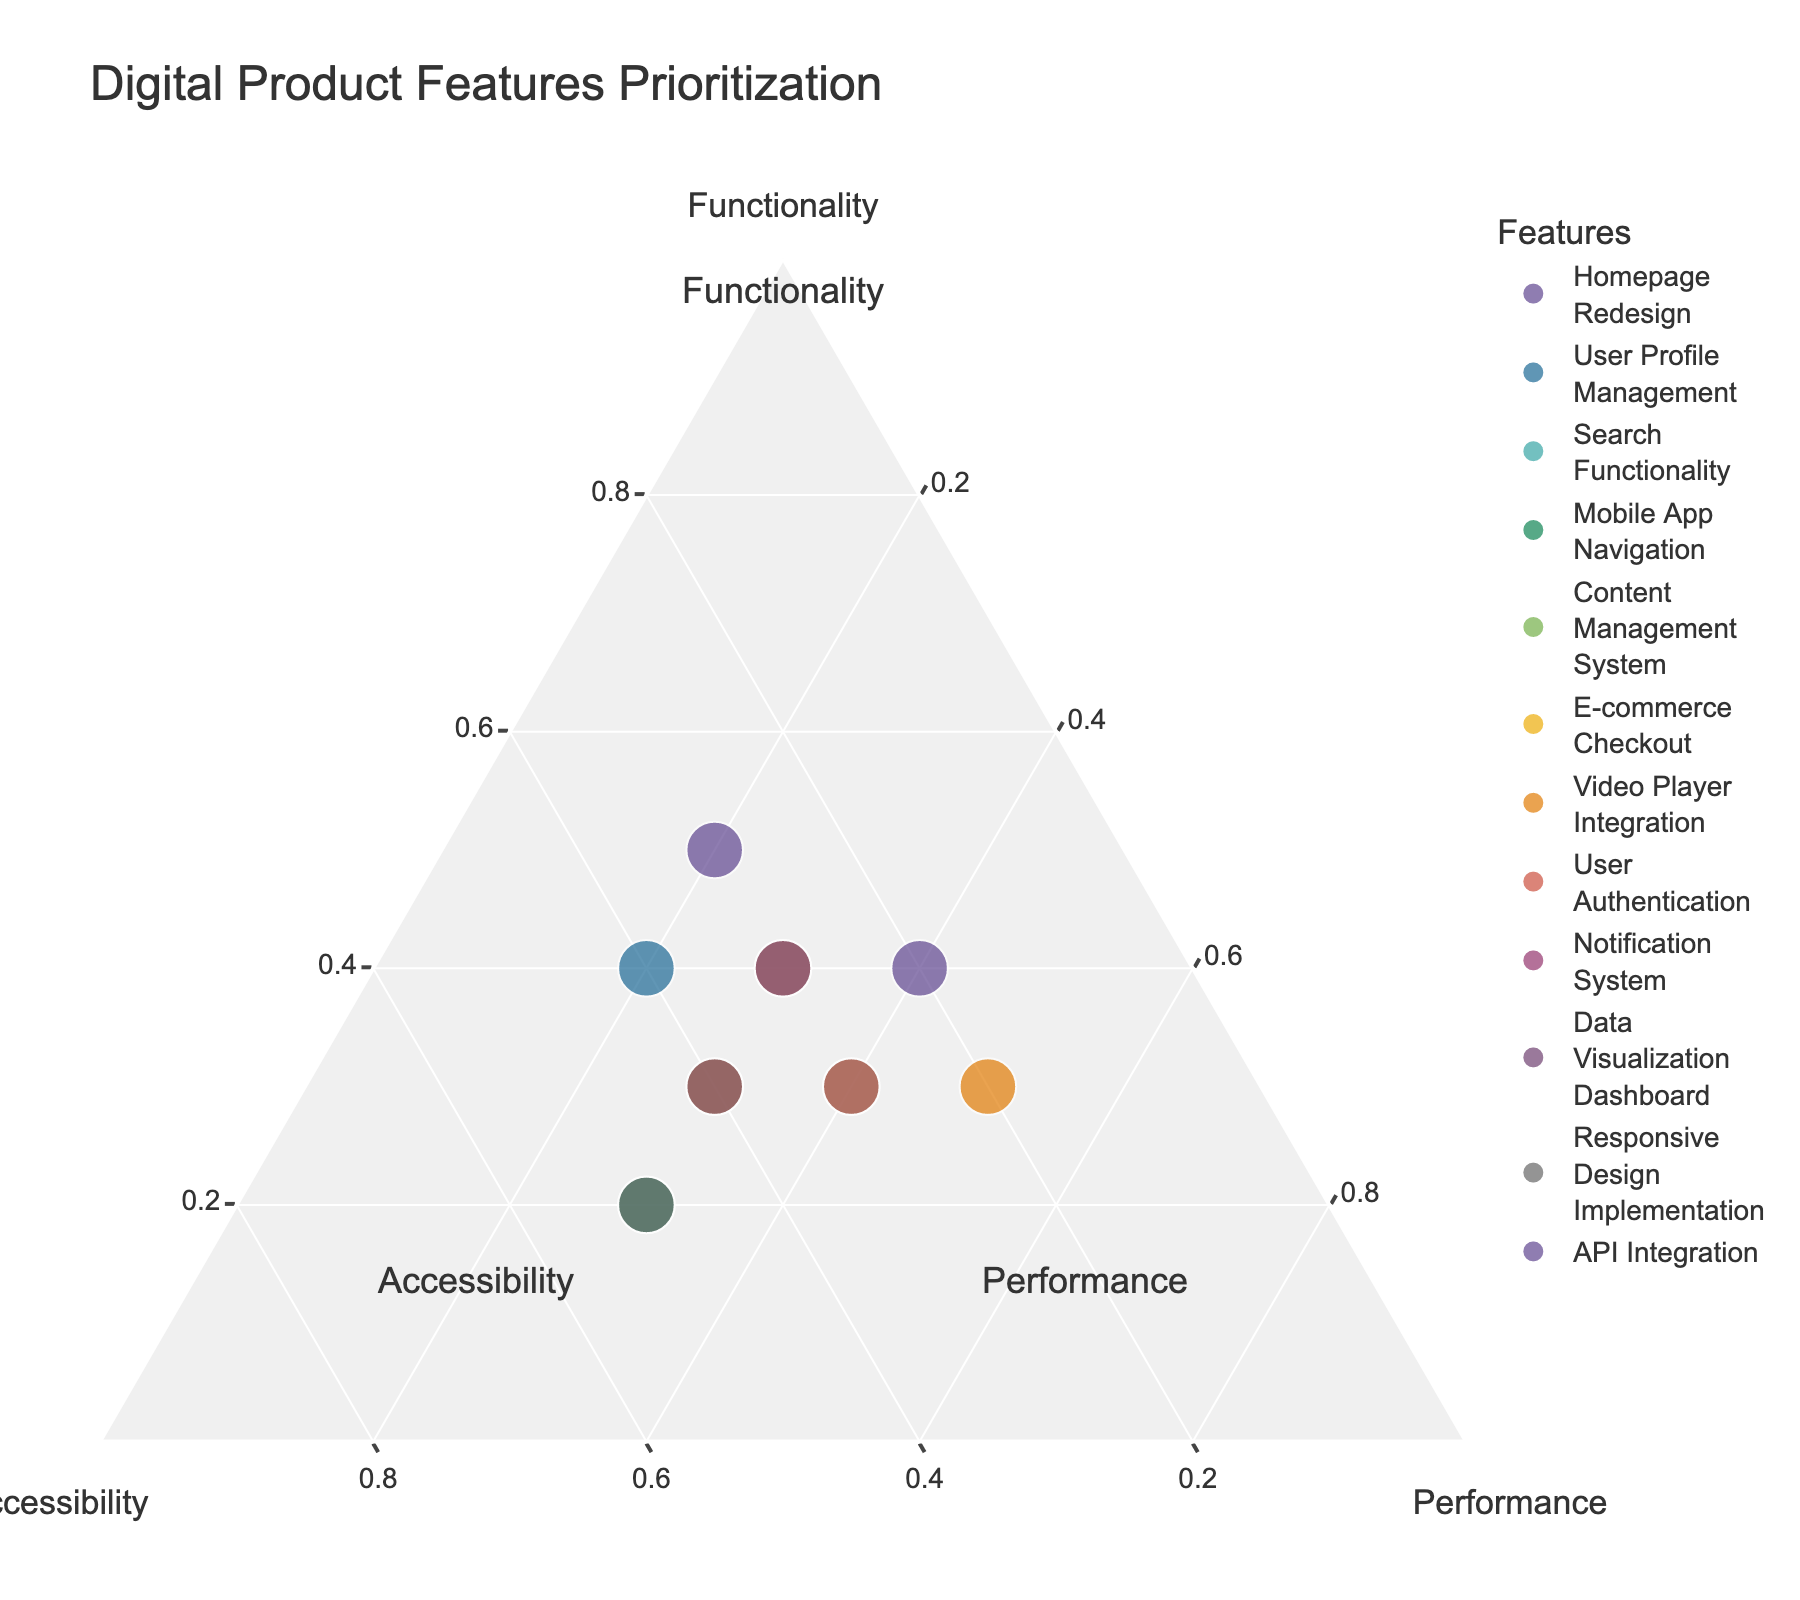What is the title of the plot? The title of the plot is displayed at the top center of the figure. It is "Digital Product Features Prioritization."
Answer: Digital Product Features Prioritization Which feature has the highest emphasis on performance? We need to find the feature placed closest to the "Performance" vertex. Looking at the data points and their positions, "Video Player Integration" has the highest performance value at 0.5.
Answer: Video Player Integration What are the three axes labeled as? The labels of the three vertices, visible as annotations around the plot, indicate the dimensions being measured: "Functionality," "Accessibility," and "Performance."
Answer: Functionality, Accessibility, Performance Which feature equally prioritizes functionality and accessibility? The data point closest to the center between "Functionality" and "Accessibility" vertices gives the clue. "User Profile Management" has values 0.4 for functionality and 0.4 for accessibility, making them equal in priority.
Answer: User Profile Management How many features have their accessibility value at 0.4? By examining the plot and locating points on the accessibility axis with a value of 0.4, we find: User Profile Management, E-commerce Checkout, and Data Visualization Dashboard.
Answer: 3 Which product feature is closest to balancing all three priorities equally? To balance all three priorities equally, the feature should lie nearest to the centroid (0.33, 0.33, 0.33). "Content Management System" appears closest with values 0.4, 0.3, and 0.3, respectively.
Answer: Content Management System Which features place higher emphasis on accessibility than on performance? Features with accessibility values greater than their performance values include: Homepage Redesign (0.3 > 0.2), User Profile Management (0.4 > 0.2), Mobile App Navigation (0.5 > 0.3), E-commerce Checkout (0.4 > 0.3), and Responsive Design Implementation (0.5 > 0.3).
Answer: Homepage Redesign, User Profile Management, Mobile App Navigation, E-commerce Checkout, Responsive Design Implementation 